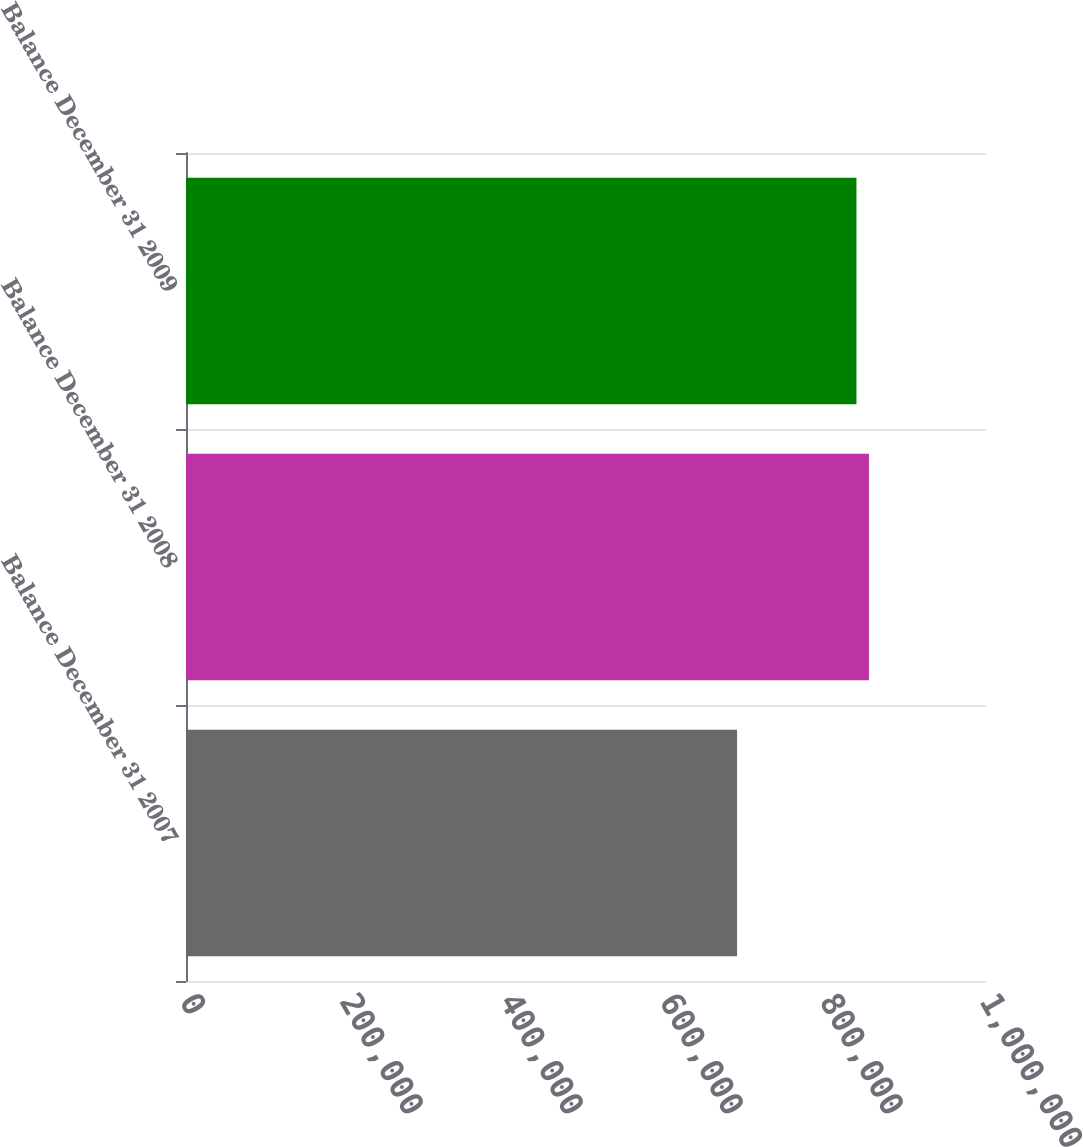Convert chart to OTSL. <chart><loc_0><loc_0><loc_500><loc_500><bar_chart><fcel>Balance December 31 2007<fcel>Balance December 31 2008<fcel>Balance December 31 2009<nl><fcel>688842<fcel>853717<fcel>838078<nl></chart> 